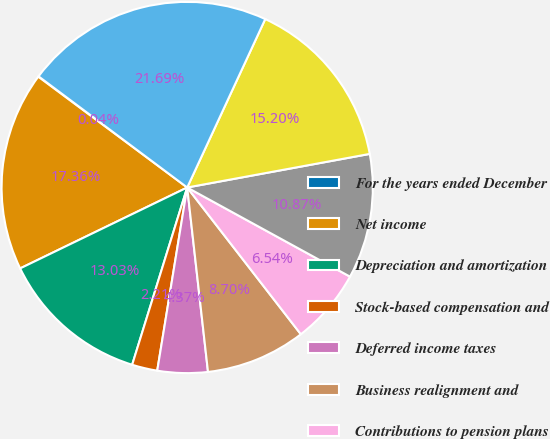Convert chart. <chart><loc_0><loc_0><loc_500><loc_500><pie_chart><fcel>For the years ended December<fcel>Net income<fcel>Depreciation and amortization<fcel>Stock-based compensation and<fcel>Deferred income taxes<fcel>Business realignment and<fcel>Contributions to pension plans<fcel>Working capital<fcel>Changes in other assets and<fcel>Net cash provided from<nl><fcel>0.04%<fcel>17.36%<fcel>13.03%<fcel>2.21%<fcel>4.37%<fcel>8.7%<fcel>6.54%<fcel>10.87%<fcel>15.2%<fcel>21.69%<nl></chart> 